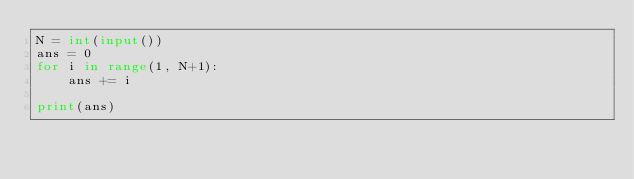<code> <loc_0><loc_0><loc_500><loc_500><_Python_>N = int(input())
ans = 0
for i in range(1, N+1):
    ans += i

print(ans)
</code> 